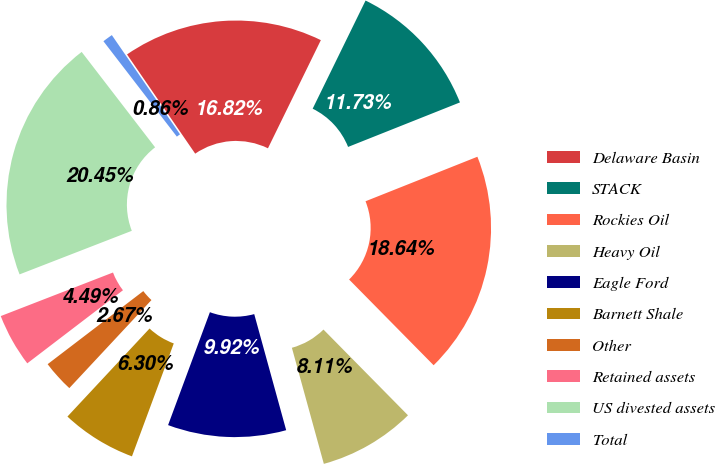<chart> <loc_0><loc_0><loc_500><loc_500><pie_chart><fcel>Delaware Basin<fcel>STACK<fcel>Rockies Oil<fcel>Heavy Oil<fcel>Eagle Ford<fcel>Barnett Shale<fcel>Other<fcel>Retained assets<fcel>US divested assets<fcel>Total<nl><fcel>16.82%<fcel>11.73%<fcel>18.64%<fcel>8.11%<fcel>9.92%<fcel>6.3%<fcel>2.67%<fcel>4.49%<fcel>20.45%<fcel>0.86%<nl></chart> 